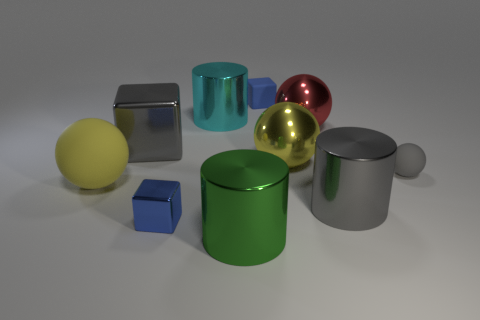Subtract all blue spheres. How many blue cubes are left? 2 Subtract all red spheres. How many spheres are left? 3 Subtract 1 blocks. How many blocks are left? 2 Subtract all red spheres. How many spheres are left? 3 Subtract all purple spheres. Subtract all brown cubes. How many spheres are left? 4 Subtract all spheres. How many objects are left? 6 Subtract 0 blue balls. How many objects are left? 10 Subtract all gray cylinders. Subtract all cylinders. How many objects are left? 6 Add 4 large green cylinders. How many large green cylinders are left? 5 Add 10 small cyan metal cylinders. How many small cyan metal cylinders exist? 10 